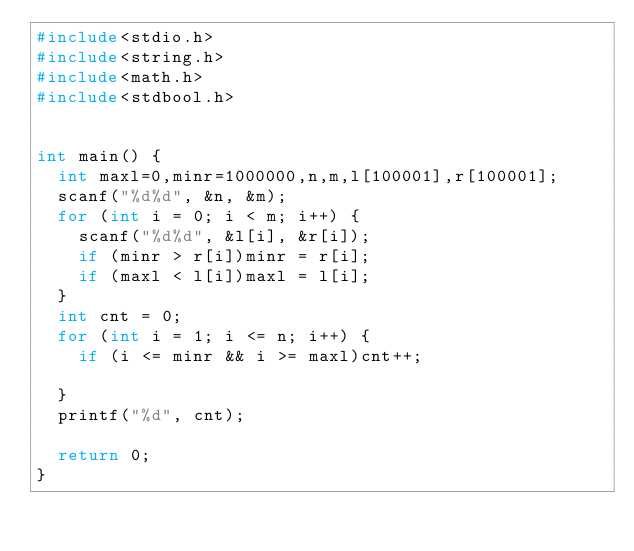<code> <loc_0><loc_0><loc_500><loc_500><_C_>#include<stdio.h>
#include<string.h>
#include<math.h>
#include<stdbool.h>


int main() {
	int maxl=0,minr=1000000,n,m,l[100001],r[100001];
	scanf("%d%d", &n, &m);
	for (int i = 0; i < m; i++) {
		scanf("%d%d", &l[i], &r[i]);
		if (minr > r[i])minr = r[i];
		if (maxl < l[i])maxl = l[i];
	}
	int cnt = 0;
	for (int i = 1; i <= n; i++) {
		if (i <= minr && i >= maxl)cnt++;

	}
	printf("%d", cnt);

	return 0;
}</code> 